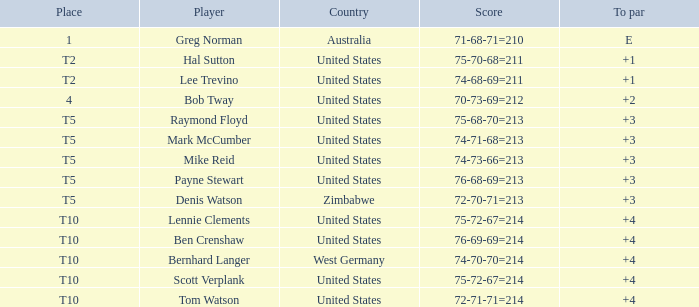What is the place of player tom watson? T10. 